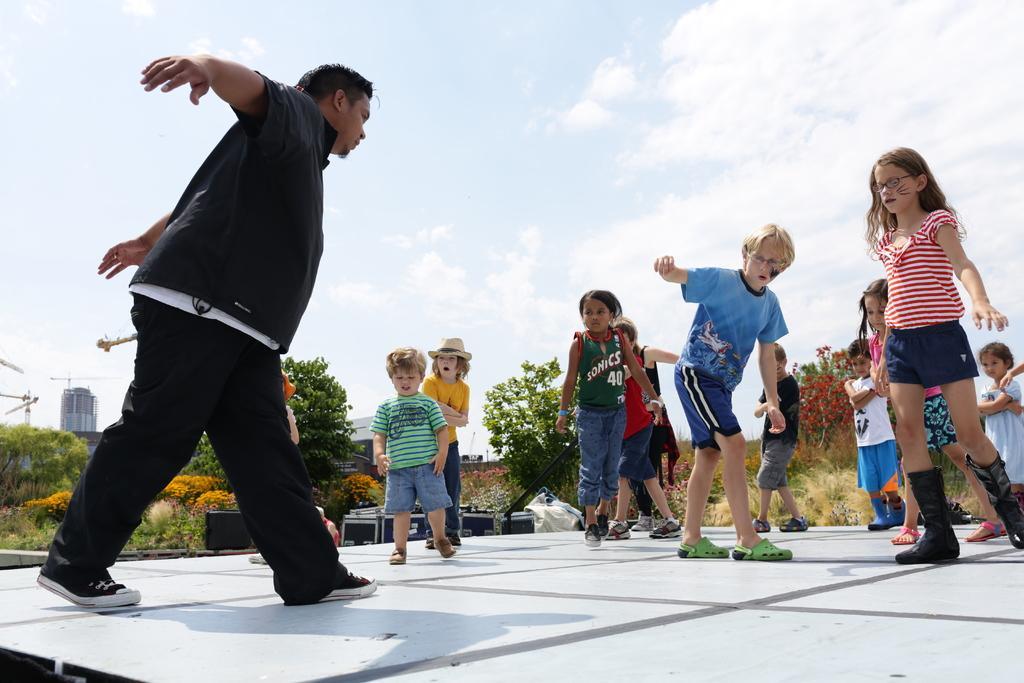How would you summarize this image in a sentence or two? In this image I can see few persons standing. In front the person is wearing black and white color dress, background I can see few plants in green color, a building in white color and the sky is also in white color. 